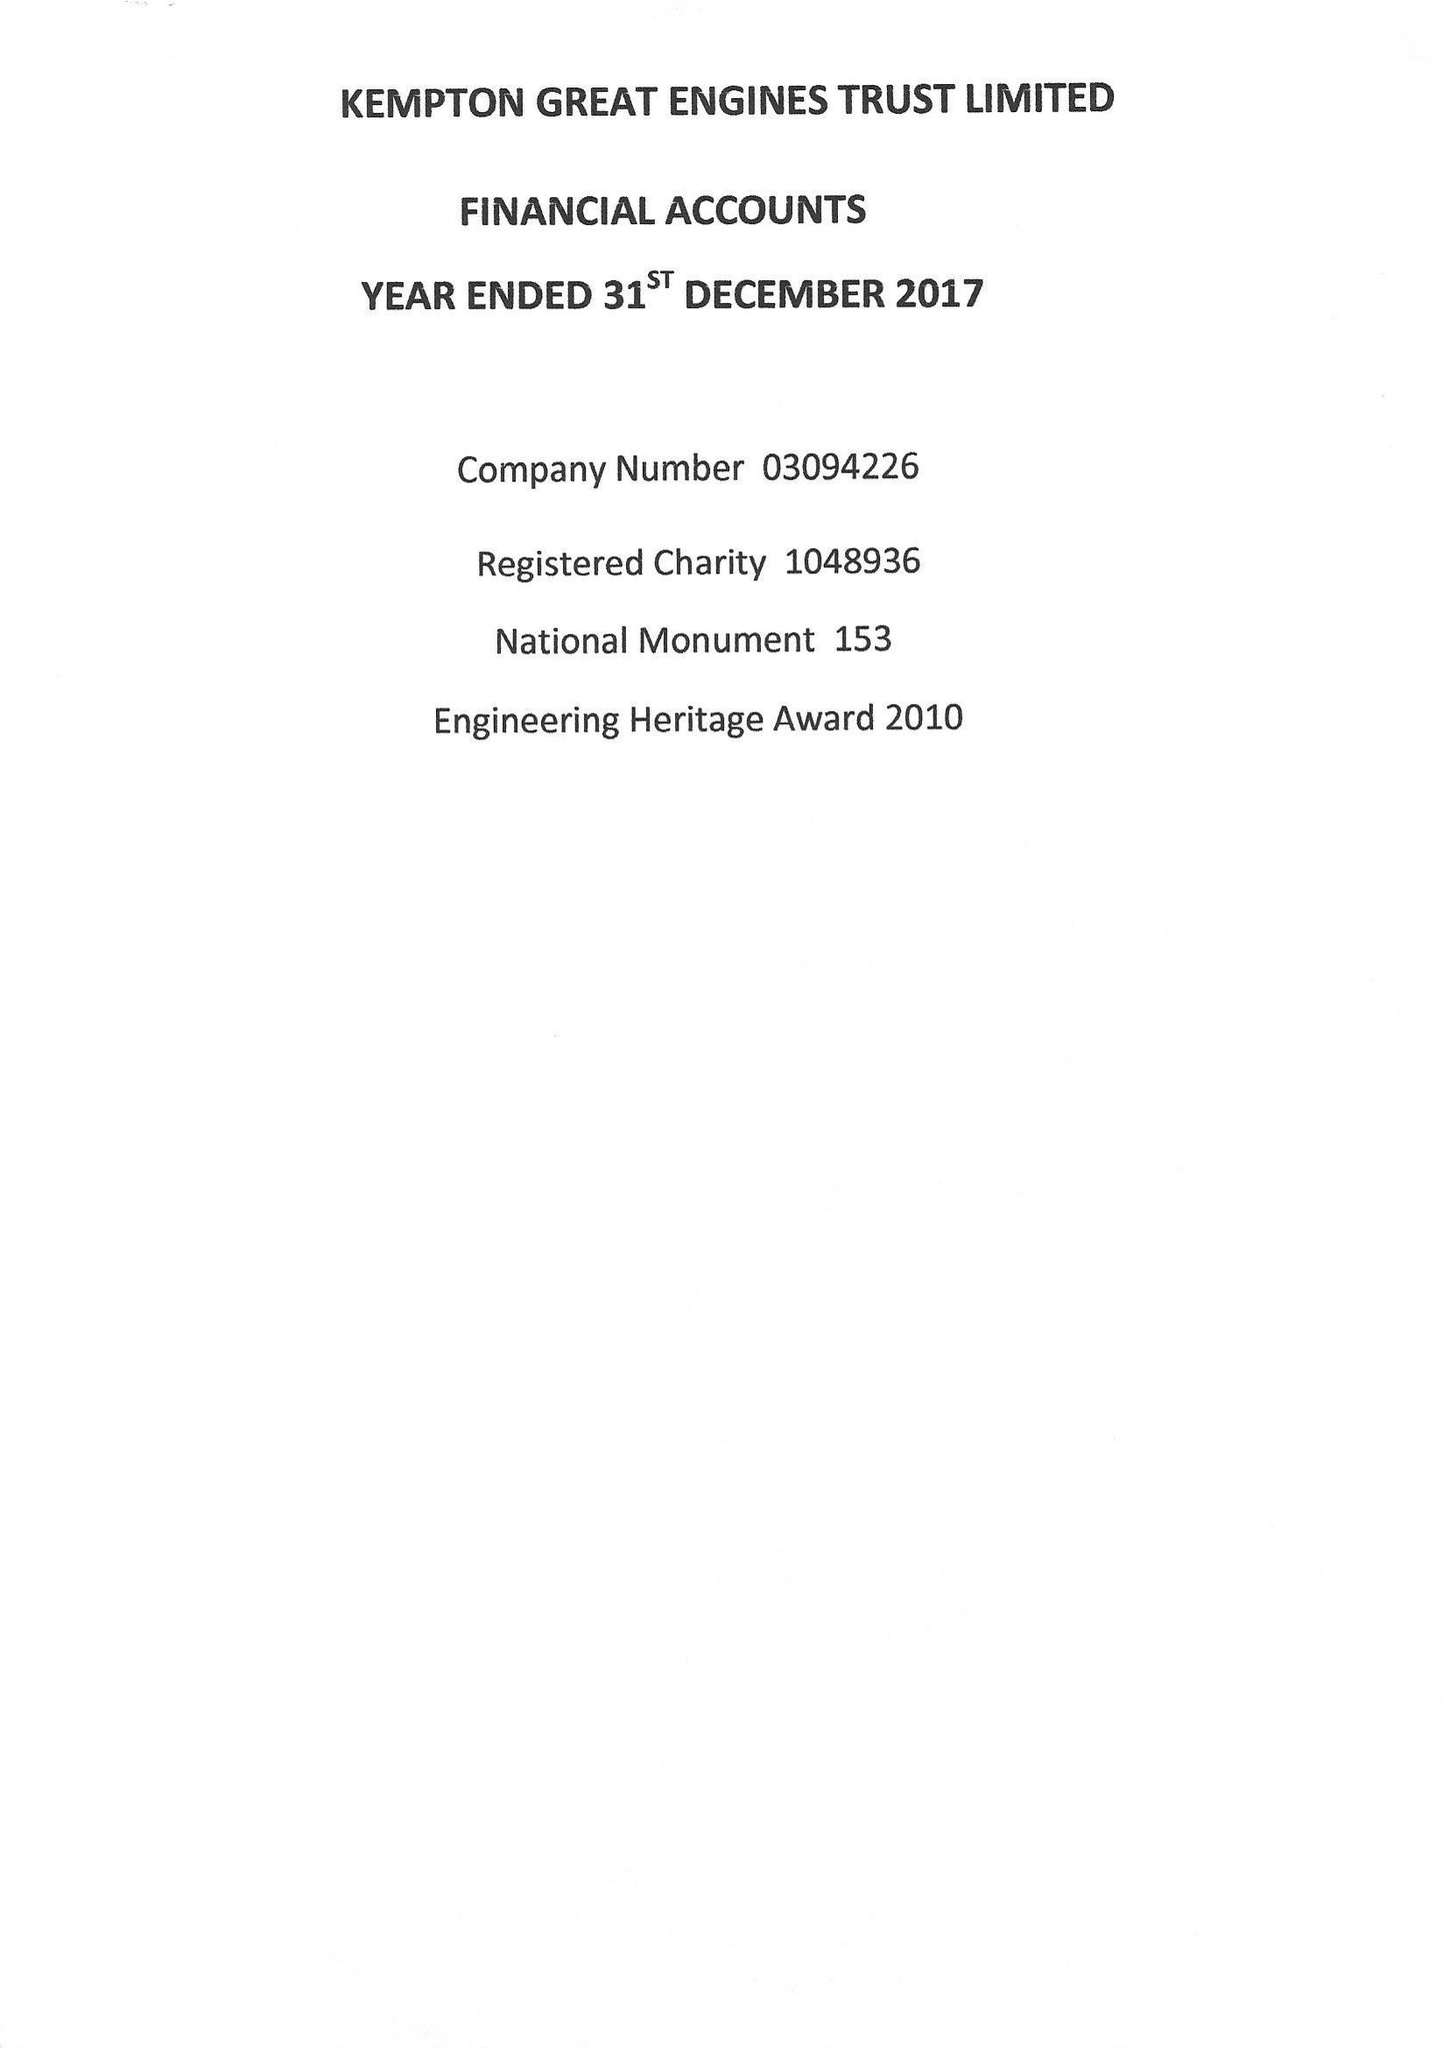What is the value for the address__post_town?
Answer the question using a single word or phrase. FELTHAM 